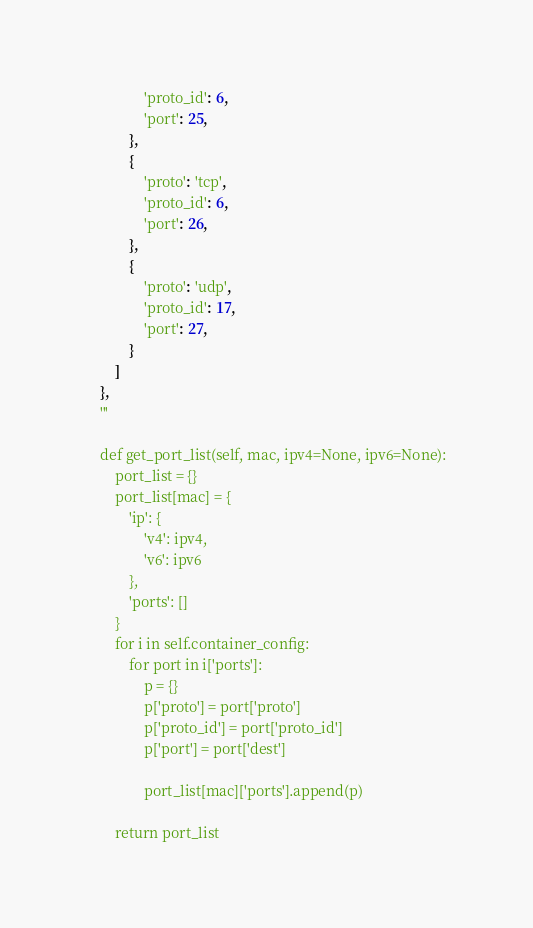Convert code to text. <code><loc_0><loc_0><loc_500><loc_500><_Python_>                'proto_id': 6,
                'port': 25,
            },
            {
                'proto': 'tcp',
                'proto_id': 6,
                'port': 26,
            },
            {
                'proto': 'udp',
                'proto_id': 17,
                'port': 27,
            }
        ]
    },
    '''

    def get_port_list(self, mac, ipv4=None, ipv6=None):
        port_list = {}
        port_list[mac] = {
            'ip': {
                'v4': ipv4,
                'v6': ipv6
            },
            'ports': []
        }
        for i in self.container_config:
            for port in i['ports']:
                p = {}
                p['proto'] = port['proto']
                p['proto_id'] = port['proto_id']
                p['port'] = port['dest']

                port_list[mac]['ports'].append(p)

        return port_list
</code> 